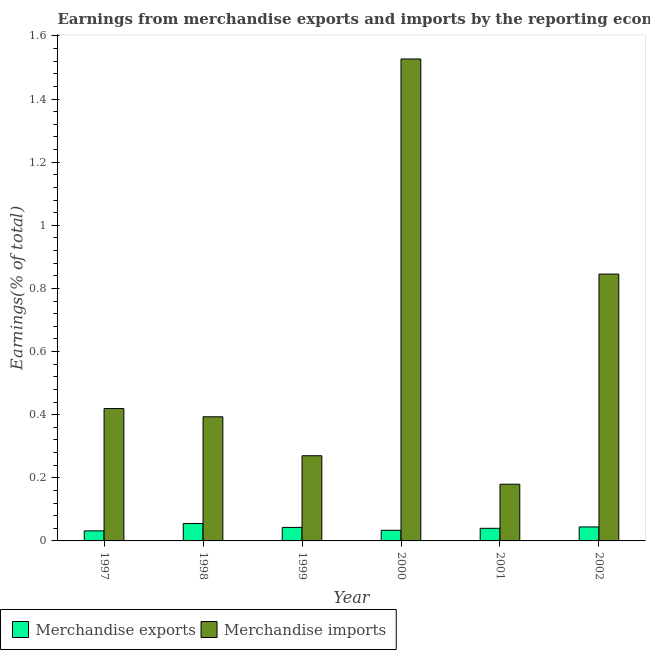How many different coloured bars are there?
Give a very brief answer. 2. How many groups of bars are there?
Offer a terse response. 6. Are the number of bars per tick equal to the number of legend labels?
Keep it short and to the point. Yes. In how many cases, is the number of bars for a given year not equal to the number of legend labels?
Offer a terse response. 0. What is the earnings from merchandise imports in 1998?
Make the answer very short. 0.39. Across all years, what is the maximum earnings from merchandise imports?
Your answer should be very brief. 1.53. Across all years, what is the minimum earnings from merchandise exports?
Keep it short and to the point. 0.03. What is the total earnings from merchandise imports in the graph?
Your answer should be very brief. 3.63. What is the difference between the earnings from merchandise imports in 1999 and that in 2002?
Offer a very short reply. -0.58. What is the difference between the earnings from merchandise imports in 1997 and the earnings from merchandise exports in 2001?
Your answer should be compact. 0.24. What is the average earnings from merchandise imports per year?
Make the answer very short. 0.61. In the year 1999, what is the difference between the earnings from merchandise imports and earnings from merchandise exports?
Provide a short and direct response. 0. What is the ratio of the earnings from merchandise imports in 1999 to that in 2002?
Ensure brevity in your answer.  0.32. What is the difference between the highest and the second highest earnings from merchandise exports?
Offer a very short reply. 0.01. What is the difference between the highest and the lowest earnings from merchandise exports?
Your answer should be compact. 0.02. In how many years, is the earnings from merchandise exports greater than the average earnings from merchandise exports taken over all years?
Offer a very short reply. 3. What does the 2nd bar from the left in 2000 represents?
Provide a succinct answer. Merchandise imports. How many bars are there?
Make the answer very short. 12. Are all the bars in the graph horizontal?
Offer a terse response. No. Are the values on the major ticks of Y-axis written in scientific E-notation?
Offer a very short reply. No. Does the graph contain any zero values?
Keep it short and to the point. No. Does the graph contain grids?
Offer a very short reply. No. Where does the legend appear in the graph?
Offer a terse response. Bottom left. How are the legend labels stacked?
Your response must be concise. Horizontal. What is the title of the graph?
Ensure brevity in your answer.  Earnings from merchandise exports and imports by the reporting economy(residual) of Saudi Arabia. Does "Urban" appear as one of the legend labels in the graph?
Provide a short and direct response. No. What is the label or title of the X-axis?
Provide a short and direct response. Year. What is the label or title of the Y-axis?
Keep it short and to the point. Earnings(% of total). What is the Earnings(% of total) in Merchandise exports in 1997?
Offer a very short reply. 0.03. What is the Earnings(% of total) of Merchandise imports in 1997?
Your answer should be compact. 0.42. What is the Earnings(% of total) of Merchandise exports in 1998?
Your response must be concise. 0.06. What is the Earnings(% of total) of Merchandise imports in 1998?
Your answer should be very brief. 0.39. What is the Earnings(% of total) in Merchandise exports in 1999?
Ensure brevity in your answer.  0.04. What is the Earnings(% of total) of Merchandise imports in 1999?
Keep it short and to the point. 0.27. What is the Earnings(% of total) in Merchandise exports in 2000?
Offer a very short reply. 0.03. What is the Earnings(% of total) in Merchandise imports in 2000?
Provide a succinct answer. 1.53. What is the Earnings(% of total) in Merchandise exports in 2001?
Ensure brevity in your answer.  0.04. What is the Earnings(% of total) in Merchandise imports in 2001?
Your answer should be compact. 0.18. What is the Earnings(% of total) of Merchandise exports in 2002?
Provide a succinct answer. 0.04. What is the Earnings(% of total) of Merchandise imports in 2002?
Your answer should be compact. 0.85. Across all years, what is the maximum Earnings(% of total) in Merchandise exports?
Ensure brevity in your answer.  0.06. Across all years, what is the maximum Earnings(% of total) in Merchandise imports?
Keep it short and to the point. 1.53. Across all years, what is the minimum Earnings(% of total) in Merchandise exports?
Offer a very short reply. 0.03. Across all years, what is the minimum Earnings(% of total) in Merchandise imports?
Offer a very short reply. 0.18. What is the total Earnings(% of total) of Merchandise exports in the graph?
Your answer should be compact. 0.25. What is the total Earnings(% of total) in Merchandise imports in the graph?
Your answer should be very brief. 3.63. What is the difference between the Earnings(% of total) in Merchandise exports in 1997 and that in 1998?
Your answer should be very brief. -0.02. What is the difference between the Earnings(% of total) of Merchandise imports in 1997 and that in 1998?
Provide a short and direct response. 0.03. What is the difference between the Earnings(% of total) of Merchandise exports in 1997 and that in 1999?
Offer a terse response. -0.01. What is the difference between the Earnings(% of total) in Merchandise imports in 1997 and that in 1999?
Make the answer very short. 0.15. What is the difference between the Earnings(% of total) of Merchandise exports in 1997 and that in 2000?
Your answer should be very brief. -0. What is the difference between the Earnings(% of total) of Merchandise imports in 1997 and that in 2000?
Keep it short and to the point. -1.11. What is the difference between the Earnings(% of total) of Merchandise exports in 1997 and that in 2001?
Offer a terse response. -0.01. What is the difference between the Earnings(% of total) in Merchandise imports in 1997 and that in 2001?
Make the answer very short. 0.24. What is the difference between the Earnings(% of total) in Merchandise exports in 1997 and that in 2002?
Provide a succinct answer. -0.01. What is the difference between the Earnings(% of total) of Merchandise imports in 1997 and that in 2002?
Your response must be concise. -0.43. What is the difference between the Earnings(% of total) in Merchandise exports in 1998 and that in 1999?
Offer a very short reply. 0.01. What is the difference between the Earnings(% of total) in Merchandise imports in 1998 and that in 1999?
Your response must be concise. 0.12. What is the difference between the Earnings(% of total) of Merchandise exports in 1998 and that in 2000?
Provide a succinct answer. 0.02. What is the difference between the Earnings(% of total) of Merchandise imports in 1998 and that in 2000?
Offer a very short reply. -1.13. What is the difference between the Earnings(% of total) in Merchandise exports in 1998 and that in 2001?
Give a very brief answer. 0.02. What is the difference between the Earnings(% of total) of Merchandise imports in 1998 and that in 2001?
Provide a short and direct response. 0.21. What is the difference between the Earnings(% of total) of Merchandise exports in 1998 and that in 2002?
Your response must be concise. 0.01. What is the difference between the Earnings(% of total) of Merchandise imports in 1998 and that in 2002?
Give a very brief answer. -0.45. What is the difference between the Earnings(% of total) in Merchandise exports in 1999 and that in 2000?
Keep it short and to the point. 0.01. What is the difference between the Earnings(% of total) in Merchandise imports in 1999 and that in 2000?
Make the answer very short. -1.26. What is the difference between the Earnings(% of total) in Merchandise exports in 1999 and that in 2001?
Provide a succinct answer. 0. What is the difference between the Earnings(% of total) in Merchandise imports in 1999 and that in 2001?
Ensure brevity in your answer.  0.09. What is the difference between the Earnings(% of total) in Merchandise exports in 1999 and that in 2002?
Give a very brief answer. -0. What is the difference between the Earnings(% of total) in Merchandise imports in 1999 and that in 2002?
Keep it short and to the point. -0.58. What is the difference between the Earnings(% of total) of Merchandise exports in 2000 and that in 2001?
Offer a terse response. -0.01. What is the difference between the Earnings(% of total) of Merchandise imports in 2000 and that in 2001?
Make the answer very short. 1.35. What is the difference between the Earnings(% of total) of Merchandise exports in 2000 and that in 2002?
Offer a terse response. -0.01. What is the difference between the Earnings(% of total) in Merchandise imports in 2000 and that in 2002?
Give a very brief answer. 0.68. What is the difference between the Earnings(% of total) in Merchandise exports in 2001 and that in 2002?
Offer a very short reply. -0. What is the difference between the Earnings(% of total) in Merchandise imports in 2001 and that in 2002?
Offer a terse response. -0.67. What is the difference between the Earnings(% of total) of Merchandise exports in 1997 and the Earnings(% of total) of Merchandise imports in 1998?
Your response must be concise. -0.36. What is the difference between the Earnings(% of total) in Merchandise exports in 1997 and the Earnings(% of total) in Merchandise imports in 1999?
Give a very brief answer. -0.24. What is the difference between the Earnings(% of total) of Merchandise exports in 1997 and the Earnings(% of total) of Merchandise imports in 2000?
Your answer should be very brief. -1.5. What is the difference between the Earnings(% of total) in Merchandise exports in 1997 and the Earnings(% of total) in Merchandise imports in 2001?
Give a very brief answer. -0.15. What is the difference between the Earnings(% of total) in Merchandise exports in 1997 and the Earnings(% of total) in Merchandise imports in 2002?
Your answer should be compact. -0.81. What is the difference between the Earnings(% of total) in Merchandise exports in 1998 and the Earnings(% of total) in Merchandise imports in 1999?
Your response must be concise. -0.21. What is the difference between the Earnings(% of total) of Merchandise exports in 1998 and the Earnings(% of total) of Merchandise imports in 2000?
Your answer should be compact. -1.47. What is the difference between the Earnings(% of total) in Merchandise exports in 1998 and the Earnings(% of total) in Merchandise imports in 2001?
Offer a very short reply. -0.12. What is the difference between the Earnings(% of total) of Merchandise exports in 1998 and the Earnings(% of total) of Merchandise imports in 2002?
Your answer should be compact. -0.79. What is the difference between the Earnings(% of total) in Merchandise exports in 1999 and the Earnings(% of total) in Merchandise imports in 2000?
Make the answer very short. -1.48. What is the difference between the Earnings(% of total) in Merchandise exports in 1999 and the Earnings(% of total) in Merchandise imports in 2001?
Your response must be concise. -0.14. What is the difference between the Earnings(% of total) of Merchandise exports in 1999 and the Earnings(% of total) of Merchandise imports in 2002?
Keep it short and to the point. -0.8. What is the difference between the Earnings(% of total) of Merchandise exports in 2000 and the Earnings(% of total) of Merchandise imports in 2001?
Offer a very short reply. -0.15. What is the difference between the Earnings(% of total) of Merchandise exports in 2000 and the Earnings(% of total) of Merchandise imports in 2002?
Offer a very short reply. -0.81. What is the difference between the Earnings(% of total) of Merchandise exports in 2001 and the Earnings(% of total) of Merchandise imports in 2002?
Ensure brevity in your answer.  -0.81. What is the average Earnings(% of total) in Merchandise exports per year?
Your answer should be compact. 0.04. What is the average Earnings(% of total) of Merchandise imports per year?
Your response must be concise. 0.61. In the year 1997, what is the difference between the Earnings(% of total) of Merchandise exports and Earnings(% of total) of Merchandise imports?
Offer a terse response. -0.39. In the year 1998, what is the difference between the Earnings(% of total) of Merchandise exports and Earnings(% of total) of Merchandise imports?
Provide a short and direct response. -0.34. In the year 1999, what is the difference between the Earnings(% of total) in Merchandise exports and Earnings(% of total) in Merchandise imports?
Provide a succinct answer. -0.23. In the year 2000, what is the difference between the Earnings(% of total) in Merchandise exports and Earnings(% of total) in Merchandise imports?
Offer a very short reply. -1.49. In the year 2001, what is the difference between the Earnings(% of total) of Merchandise exports and Earnings(% of total) of Merchandise imports?
Keep it short and to the point. -0.14. In the year 2002, what is the difference between the Earnings(% of total) of Merchandise exports and Earnings(% of total) of Merchandise imports?
Keep it short and to the point. -0.8. What is the ratio of the Earnings(% of total) in Merchandise exports in 1997 to that in 1998?
Provide a succinct answer. 0.58. What is the ratio of the Earnings(% of total) of Merchandise imports in 1997 to that in 1998?
Provide a short and direct response. 1.07. What is the ratio of the Earnings(% of total) of Merchandise exports in 1997 to that in 1999?
Ensure brevity in your answer.  0.75. What is the ratio of the Earnings(% of total) of Merchandise imports in 1997 to that in 1999?
Provide a short and direct response. 1.55. What is the ratio of the Earnings(% of total) in Merchandise exports in 1997 to that in 2000?
Keep it short and to the point. 0.94. What is the ratio of the Earnings(% of total) of Merchandise imports in 1997 to that in 2000?
Offer a very short reply. 0.27. What is the ratio of the Earnings(% of total) in Merchandise exports in 1997 to that in 2001?
Make the answer very short. 0.8. What is the ratio of the Earnings(% of total) in Merchandise imports in 1997 to that in 2001?
Keep it short and to the point. 2.33. What is the ratio of the Earnings(% of total) in Merchandise exports in 1997 to that in 2002?
Ensure brevity in your answer.  0.72. What is the ratio of the Earnings(% of total) of Merchandise imports in 1997 to that in 2002?
Give a very brief answer. 0.5. What is the ratio of the Earnings(% of total) of Merchandise exports in 1998 to that in 1999?
Your answer should be very brief. 1.29. What is the ratio of the Earnings(% of total) of Merchandise imports in 1998 to that in 1999?
Your answer should be very brief. 1.46. What is the ratio of the Earnings(% of total) in Merchandise exports in 1998 to that in 2000?
Ensure brevity in your answer.  1.63. What is the ratio of the Earnings(% of total) in Merchandise imports in 1998 to that in 2000?
Provide a succinct answer. 0.26. What is the ratio of the Earnings(% of total) of Merchandise exports in 1998 to that in 2001?
Your response must be concise. 1.38. What is the ratio of the Earnings(% of total) of Merchandise imports in 1998 to that in 2001?
Offer a terse response. 2.19. What is the ratio of the Earnings(% of total) in Merchandise exports in 1998 to that in 2002?
Provide a succinct answer. 1.24. What is the ratio of the Earnings(% of total) in Merchandise imports in 1998 to that in 2002?
Your answer should be compact. 0.47. What is the ratio of the Earnings(% of total) of Merchandise exports in 1999 to that in 2000?
Offer a terse response. 1.27. What is the ratio of the Earnings(% of total) in Merchandise imports in 1999 to that in 2000?
Offer a very short reply. 0.18. What is the ratio of the Earnings(% of total) of Merchandise exports in 1999 to that in 2001?
Offer a very short reply. 1.07. What is the ratio of the Earnings(% of total) of Merchandise imports in 1999 to that in 2001?
Keep it short and to the point. 1.5. What is the ratio of the Earnings(% of total) in Merchandise exports in 1999 to that in 2002?
Your response must be concise. 0.96. What is the ratio of the Earnings(% of total) in Merchandise imports in 1999 to that in 2002?
Provide a short and direct response. 0.32. What is the ratio of the Earnings(% of total) of Merchandise exports in 2000 to that in 2001?
Make the answer very short. 0.84. What is the ratio of the Earnings(% of total) of Merchandise imports in 2000 to that in 2001?
Keep it short and to the point. 8.5. What is the ratio of the Earnings(% of total) of Merchandise exports in 2000 to that in 2002?
Keep it short and to the point. 0.76. What is the ratio of the Earnings(% of total) in Merchandise imports in 2000 to that in 2002?
Your answer should be very brief. 1.81. What is the ratio of the Earnings(% of total) of Merchandise exports in 2001 to that in 2002?
Ensure brevity in your answer.  0.9. What is the ratio of the Earnings(% of total) of Merchandise imports in 2001 to that in 2002?
Ensure brevity in your answer.  0.21. What is the difference between the highest and the second highest Earnings(% of total) in Merchandise exports?
Your response must be concise. 0.01. What is the difference between the highest and the second highest Earnings(% of total) of Merchandise imports?
Your answer should be compact. 0.68. What is the difference between the highest and the lowest Earnings(% of total) in Merchandise exports?
Your answer should be very brief. 0.02. What is the difference between the highest and the lowest Earnings(% of total) of Merchandise imports?
Offer a very short reply. 1.35. 